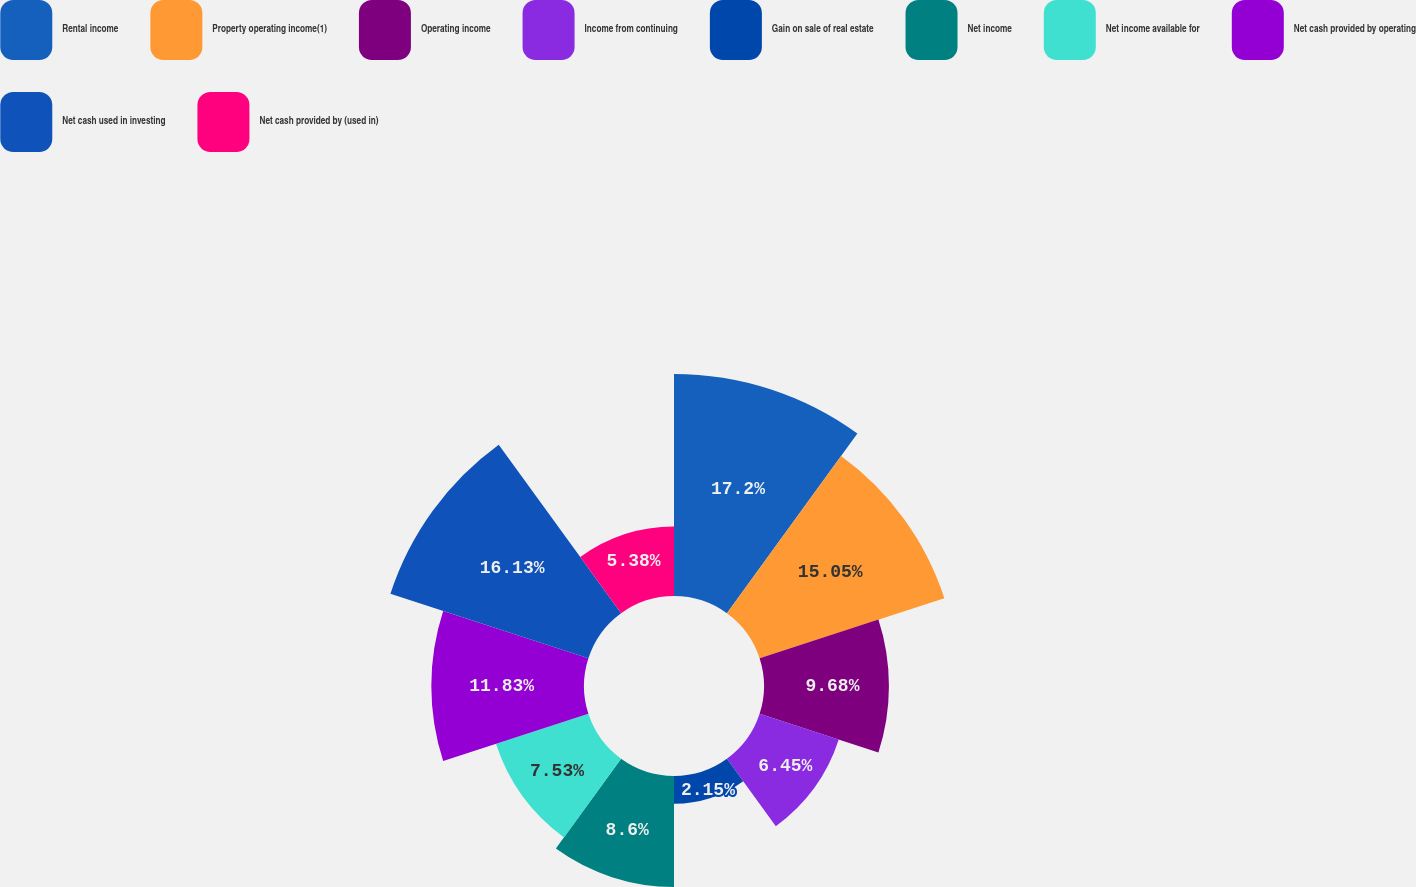<chart> <loc_0><loc_0><loc_500><loc_500><pie_chart><fcel>Rental income<fcel>Property operating income(1)<fcel>Operating income<fcel>Income from continuing<fcel>Gain on sale of real estate<fcel>Net income<fcel>Net income available for<fcel>Net cash provided by operating<fcel>Net cash used in investing<fcel>Net cash provided by (used in)<nl><fcel>17.2%<fcel>15.05%<fcel>9.68%<fcel>6.45%<fcel>2.15%<fcel>8.6%<fcel>7.53%<fcel>11.83%<fcel>16.13%<fcel>5.38%<nl></chart> 